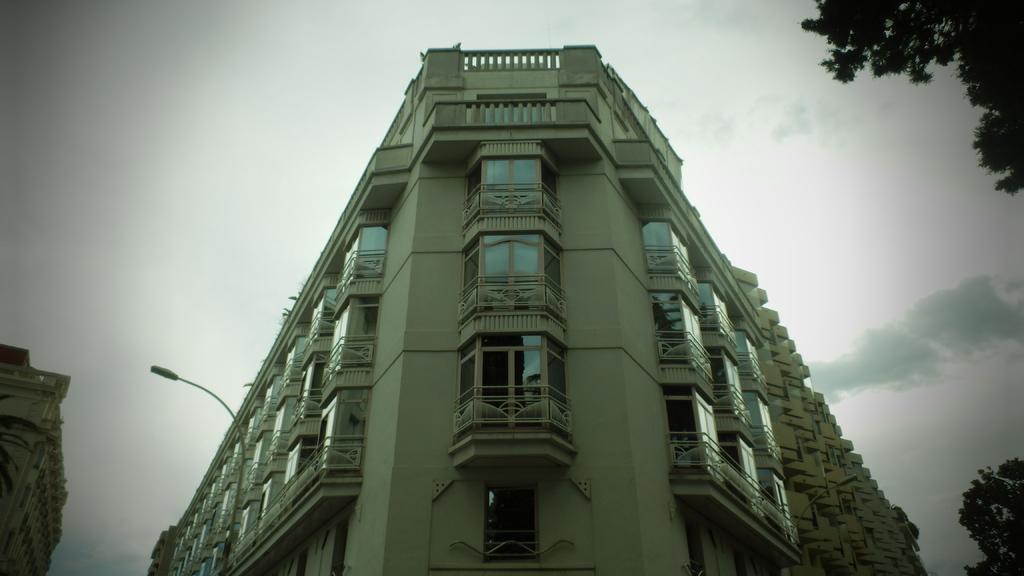Please provide a concise description of this image. In this image we can see few buildings and they are having many windows. There are few trees in the image. We can see the sky in the image. We can see the clouds at the right side of the image. We can see a street light in the image. 